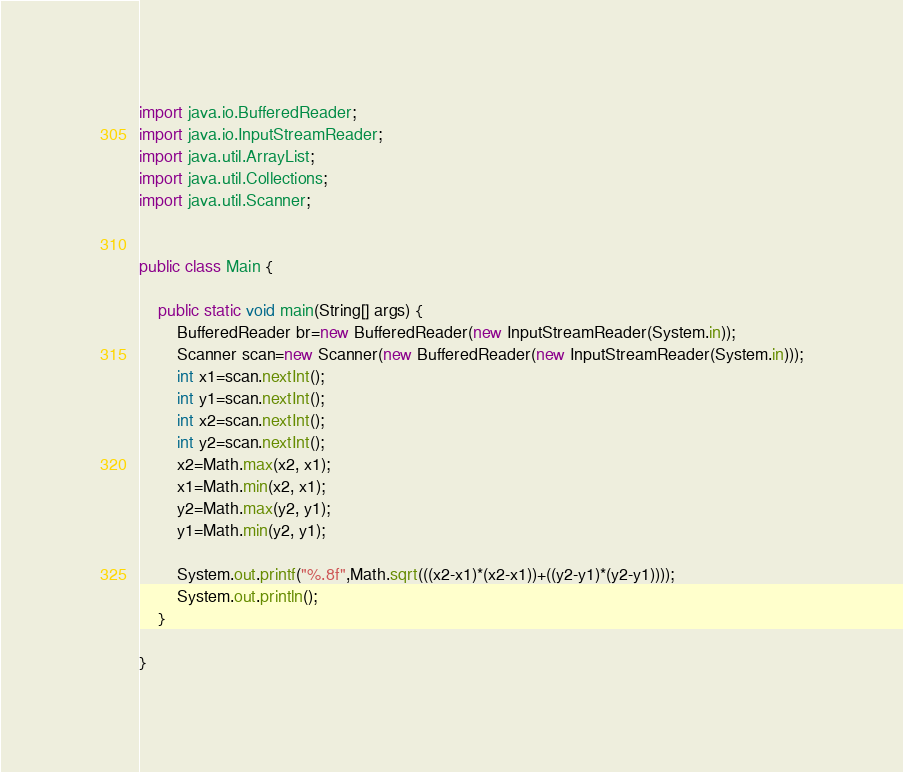Convert code to text. <code><loc_0><loc_0><loc_500><loc_500><_Java_>import java.io.BufferedReader;
import java.io.InputStreamReader;
import java.util.ArrayList;
import java.util.Collections;
import java.util.Scanner;


public class Main {

	public static void main(String[] args) {
		BufferedReader br=new BufferedReader(new InputStreamReader(System.in));
		Scanner scan=new Scanner(new BufferedReader(new InputStreamReader(System.in)));
		int x1=scan.nextInt();
		int y1=scan.nextInt();
		int x2=scan.nextInt();
		int y2=scan.nextInt();
		x2=Math.max(x2, x1);
		x1=Math.min(x2, x1);
		y2=Math.max(y2, y1);
		y1=Math.min(y2, y1);
		
		System.out.printf("%.8f",Math.sqrt(((x2-x1)*(x2-x1))+((y2-y1)*(y2-y1))));
		System.out.println();
	}

}</code> 